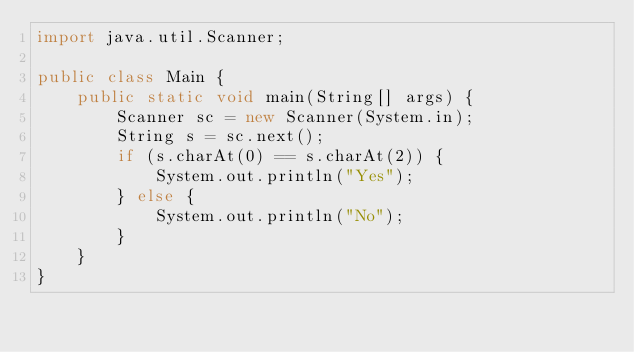Convert code to text. <code><loc_0><loc_0><loc_500><loc_500><_Java_>import java.util.Scanner;

public class Main {
    public static void main(String[] args) {
        Scanner sc = new Scanner(System.in);
        String s = sc.next();
        if (s.charAt(0) == s.charAt(2)) {
            System.out.println("Yes");
        } else {
            System.out.println("No");
        }
    }
}</code> 